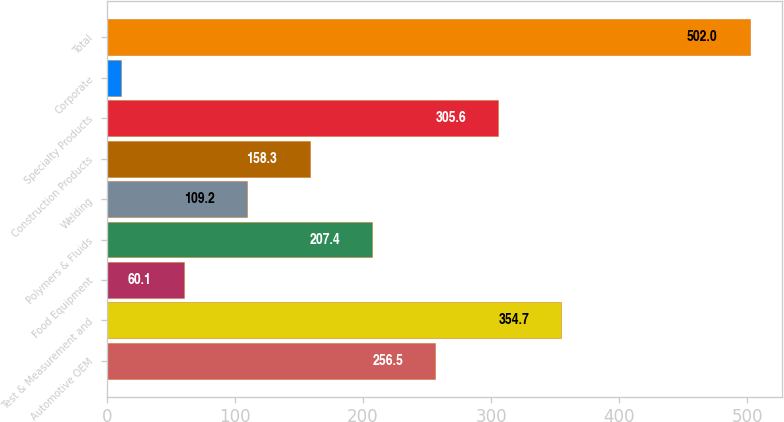Convert chart to OTSL. <chart><loc_0><loc_0><loc_500><loc_500><bar_chart><fcel>Automotive OEM<fcel>Test & Measurement and<fcel>Food Equipment<fcel>Polymers & Fluids<fcel>Welding<fcel>Construction Products<fcel>Specialty Products<fcel>Corporate<fcel>Total<nl><fcel>256.5<fcel>354.7<fcel>60.1<fcel>207.4<fcel>109.2<fcel>158.3<fcel>305.6<fcel>11<fcel>502<nl></chart> 